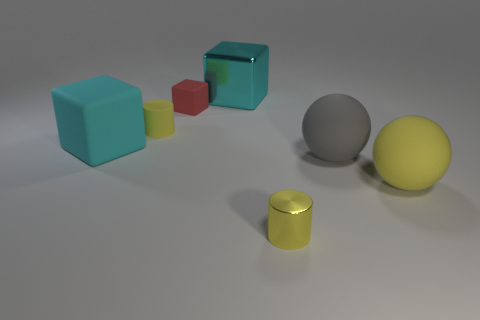There is a tiny object that is in front of the tiny red matte object and behind the yellow ball; what is its shape?
Provide a succinct answer. Cylinder. Are there any red objects?
Offer a very short reply. Yes. There is another big cyan thing that is the same shape as the large cyan metallic thing; what is it made of?
Offer a terse response. Rubber. There is a metal thing behind the large rubber thing to the left of the big thing behind the red block; what shape is it?
Give a very brief answer. Cube. There is a large sphere that is the same color as the tiny rubber cylinder; what material is it?
Give a very brief answer. Rubber. What number of tiny green objects have the same shape as the large yellow rubber object?
Give a very brief answer. 0. Is the color of the object behind the small matte block the same as the big rubber thing on the left side of the yellow metal thing?
Provide a succinct answer. Yes. What is the material of the block that is the same size as the yellow matte cylinder?
Keep it short and to the point. Rubber. Is there a cylinder that has the same size as the red rubber cube?
Your response must be concise. Yes. Are there fewer shiny things that are in front of the large yellow sphere than tiny brown shiny things?
Make the answer very short. No. 